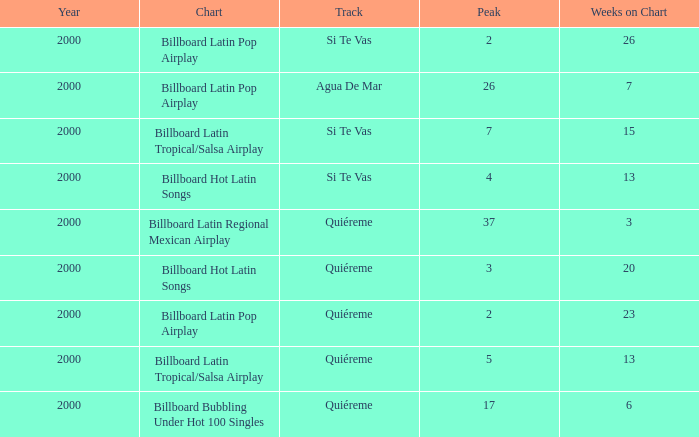Name the total number of weeks for si te vas and peak less than 7 and year less than 2000 0.0. 